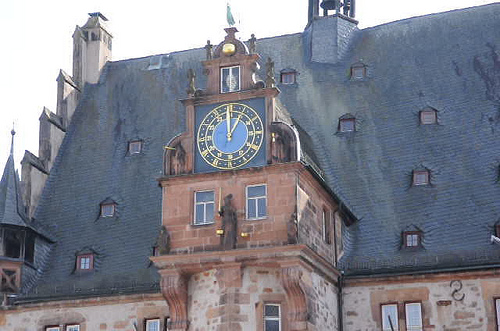What function might the tower of this building serve? The tower, crowned with a clock, suggests that this building may have served a civic purpose, such as a town hall or other municipal function where the time display would have been essential for the community's daily activities. Can you tell the time from the clock in the image? The clock hands indicate the time as approximately 5:50. However, without knowledge of the clock's functionality and current maintenance, I can't confirm if this time is accurate at the moment the photo was taken. 